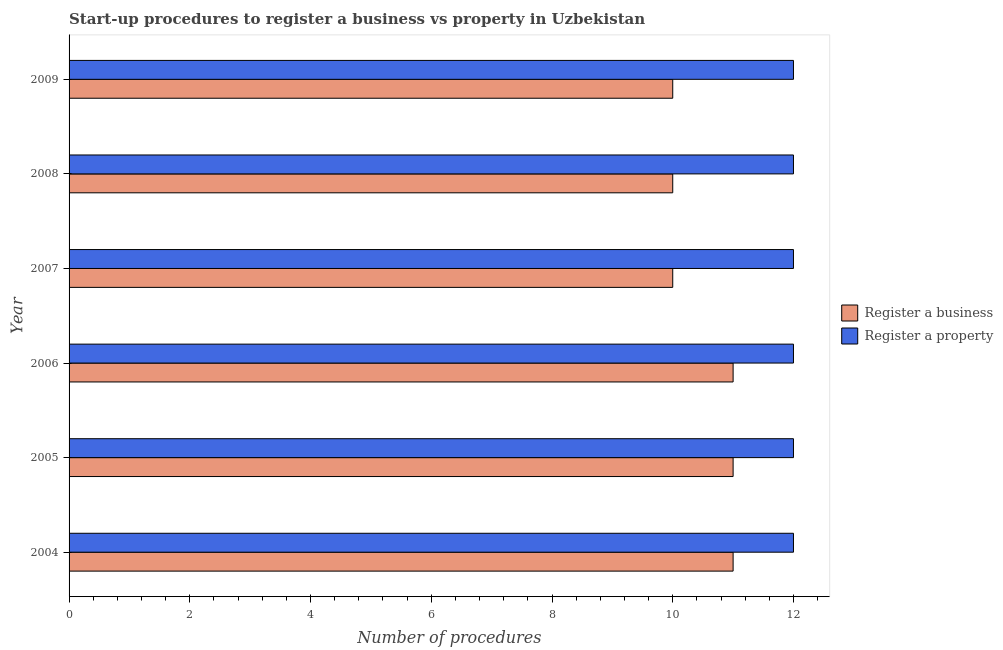How many groups of bars are there?
Provide a short and direct response. 6. Are the number of bars per tick equal to the number of legend labels?
Offer a terse response. Yes. Are the number of bars on each tick of the Y-axis equal?
Give a very brief answer. Yes. How many bars are there on the 6th tick from the top?
Your response must be concise. 2. How many bars are there on the 3rd tick from the bottom?
Your response must be concise. 2. What is the label of the 1st group of bars from the top?
Offer a very short reply. 2009. What is the number of procedures to register a business in 2007?
Your answer should be very brief. 10. Across all years, what is the maximum number of procedures to register a property?
Make the answer very short. 12. Across all years, what is the minimum number of procedures to register a property?
Offer a very short reply. 12. In which year was the number of procedures to register a property minimum?
Your answer should be very brief. 2004. What is the total number of procedures to register a property in the graph?
Your response must be concise. 72. What is the difference between the number of procedures to register a business in 2006 and that in 2009?
Your response must be concise. 1. What is the difference between the number of procedures to register a property in 2009 and the number of procedures to register a business in 2005?
Keep it short and to the point. 1. What is the average number of procedures to register a business per year?
Provide a short and direct response. 10.5. In the year 2006, what is the difference between the number of procedures to register a property and number of procedures to register a business?
Offer a terse response. 1. Is the number of procedures to register a property in 2005 less than that in 2006?
Keep it short and to the point. No. What is the difference between the highest and the lowest number of procedures to register a business?
Keep it short and to the point. 1. Is the sum of the number of procedures to register a business in 2006 and 2007 greater than the maximum number of procedures to register a property across all years?
Offer a very short reply. Yes. What does the 1st bar from the top in 2004 represents?
Make the answer very short. Register a property. What does the 2nd bar from the bottom in 2008 represents?
Your answer should be compact. Register a property. Are all the bars in the graph horizontal?
Keep it short and to the point. Yes. Are the values on the major ticks of X-axis written in scientific E-notation?
Provide a short and direct response. No. Where does the legend appear in the graph?
Your answer should be very brief. Center right. What is the title of the graph?
Your response must be concise. Start-up procedures to register a business vs property in Uzbekistan. What is the label or title of the X-axis?
Your answer should be very brief. Number of procedures. What is the Number of procedures of Register a business in 2004?
Offer a very short reply. 11. What is the Number of procedures in Register a property in 2004?
Provide a succinct answer. 12. What is the Number of procedures of Register a business in 2005?
Offer a very short reply. 11. What is the Number of procedures of Register a business in 2006?
Offer a terse response. 11. What is the Number of procedures in Register a property in 2006?
Your answer should be compact. 12. What is the Number of procedures in Register a business in 2007?
Your answer should be very brief. 10. What is the Number of procedures of Register a business in 2008?
Your answer should be very brief. 10. What is the Number of procedures in Register a property in 2008?
Your answer should be very brief. 12. What is the Number of procedures of Register a business in 2009?
Provide a short and direct response. 10. What is the Number of procedures in Register a property in 2009?
Make the answer very short. 12. Across all years, what is the maximum Number of procedures of Register a property?
Your response must be concise. 12. What is the total Number of procedures of Register a business in the graph?
Give a very brief answer. 63. What is the difference between the Number of procedures of Register a business in 2004 and that in 2005?
Make the answer very short. 0. What is the difference between the Number of procedures in Register a property in 2004 and that in 2007?
Make the answer very short. 0. What is the difference between the Number of procedures of Register a business in 2004 and that in 2009?
Offer a very short reply. 1. What is the difference between the Number of procedures in Register a property in 2004 and that in 2009?
Give a very brief answer. 0. What is the difference between the Number of procedures in Register a business in 2005 and that in 2007?
Ensure brevity in your answer.  1. What is the difference between the Number of procedures in Register a property in 2005 and that in 2007?
Make the answer very short. 0. What is the difference between the Number of procedures of Register a property in 2005 and that in 2008?
Offer a terse response. 0. What is the difference between the Number of procedures of Register a property in 2005 and that in 2009?
Ensure brevity in your answer.  0. What is the difference between the Number of procedures in Register a property in 2006 and that in 2007?
Make the answer very short. 0. What is the difference between the Number of procedures in Register a business in 2006 and that in 2009?
Ensure brevity in your answer.  1. What is the difference between the Number of procedures of Register a property in 2006 and that in 2009?
Offer a terse response. 0. What is the difference between the Number of procedures in Register a business in 2007 and that in 2009?
Make the answer very short. 0. What is the difference between the Number of procedures in Register a business in 2008 and that in 2009?
Your answer should be compact. 0. What is the difference between the Number of procedures in Register a property in 2008 and that in 2009?
Make the answer very short. 0. What is the difference between the Number of procedures in Register a business in 2004 and the Number of procedures in Register a property in 2006?
Ensure brevity in your answer.  -1. What is the difference between the Number of procedures of Register a business in 2004 and the Number of procedures of Register a property in 2008?
Offer a very short reply. -1. What is the difference between the Number of procedures of Register a business in 2004 and the Number of procedures of Register a property in 2009?
Offer a very short reply. -1. What is the difference between the Number of procedures in Register a business in 2005 and the Number of procedures in Register a property in 2007?
Provide a succinct answer. -1. What is the difference between the Number of procedures in Register a business in 2005 and the Number of procedures in Register a property in 2009?
Your answer should be compact. -1. What is the difference between the Number of procedures in Register a business in 2006 and the Number of procedures in Register a property in 2008?
Your answer should be very brief. -1. What is the difference between the Number of procedures of Register a business in 2007 and the Number of procedures of Register a property in 2009?
Give a very brief answer. -2. What is the difference between the Number of procedures of Register a business in 2008 and the Number of procedures of Register a property in 2009?
Provide a succinct answer. -2. What is the average Number of procedures of Register a property per year?
Your answer should be compact. 12. In the year 2007, what is the difference between the Number of procedures of Register a business and Number of procedures of Register a property?
Your answer should be compact. -2. In the year 2008, what is the difference between the Number of procedures of Register a business and Number of procedures of Register a property?
Keep it short and to the point. -2. What is the ratio of the Number of procedures in Register a business in 2004 to that in 2005?
Your answer should be compact. 1. What is the ratio of the Number of procedures of Register a property in 2004 to that in 2005?
Your answer should be compact. 1. What is the ratio of the Number of procedures in Register a business in 2004 to that in 2006?
Your answer should be very brief. 1. What is the ratio of the Number of procedures in Register a property in 2004 to that in 2006?
Provide a succinct answer. 1. What is the ratio of the Number of procedures of Register a business in 2004 to that in 2007?
Offer a very short reply. 1.1. What is the ratio of the Number of procedures in Register a property in 2004 to that in 2007?
Offer a terse response. 1. What is the ratio of the Number of procedures in Register a property in 2004 to that in 2008?
Offer a terse response. 1. What is the ratio of the Number of procedures of Register a property in 2004 to that in 2009?
Provide a short and direct response. 1. What is the ratio of the Number of procedures of Register a business in 2005 to that in 2008?
Your response must be concise. 1.1. What is the ratio of the Number of procedures in Register a property in 2005 to that in 2008?
Ensure brevity in your answer.  1. What is the ratio of the Number of procedures in Register a property in 2005 to that in 2009?
Ensure brevity in your answer.  1. What is the ratio of the Number of procedures in Register a business in 2006 to that in 2007?
Offer a very short reply. 1.1. What is the ratio of the Number of procedures of Register a business in 2007 to that in 2009?
Make the answer very short. 1. What is the ratio of the Number of procedures in Register a property in 2007 to that in 2009?
Your answer should be very brief. 1. What is the difference between the highest and the second highest Number of procedures of Register a business?
Give a very brief answer. 0. What is the difference between the highest and the second highest Number of procedures in Register a property?
Your answer should be very brief. 0. What is the difference between the highest and the lowest Number of procedures of Register a business?
Ensure brevity in your answer.  1. 